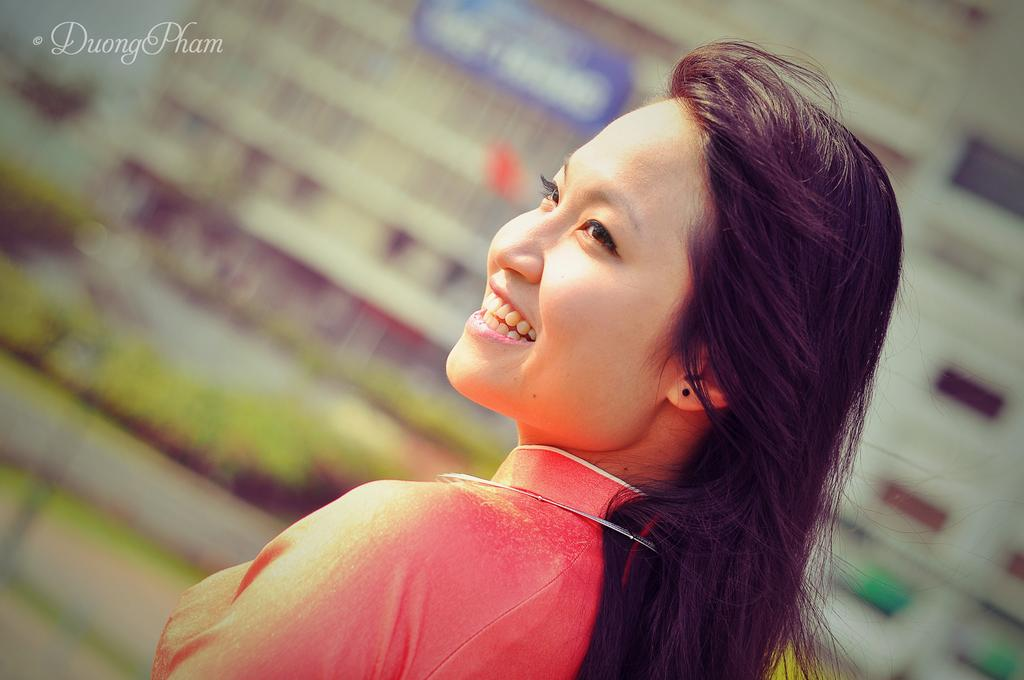Who is the main subject in the image? There is a woman in the image. What is the woman wearing? The woman is wearing an orange dress. What is the woman's facial expression in the image? The woman is smiling. Can you describe any additional features of the image? There is a watermark in the top left corner of the image, and the background is blurred. What is the woman's reaction to the shocking news she just heard in the image? There is no indication in the image that the woman has heard any news, shocking or otherwise, as she is simply smiling. 